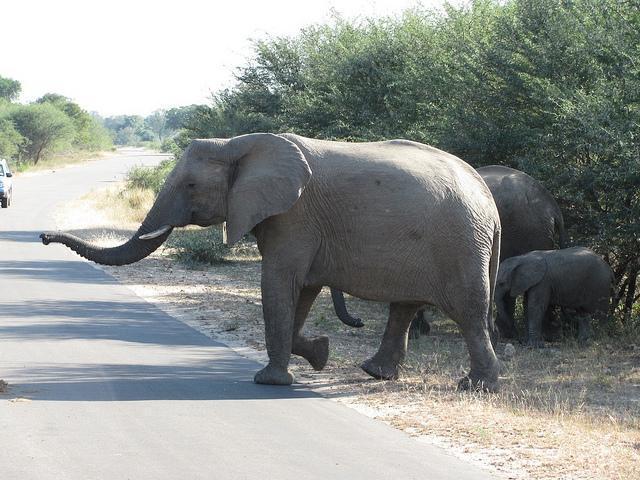How many elephants are visible?
Give a very brief answer. 3. 